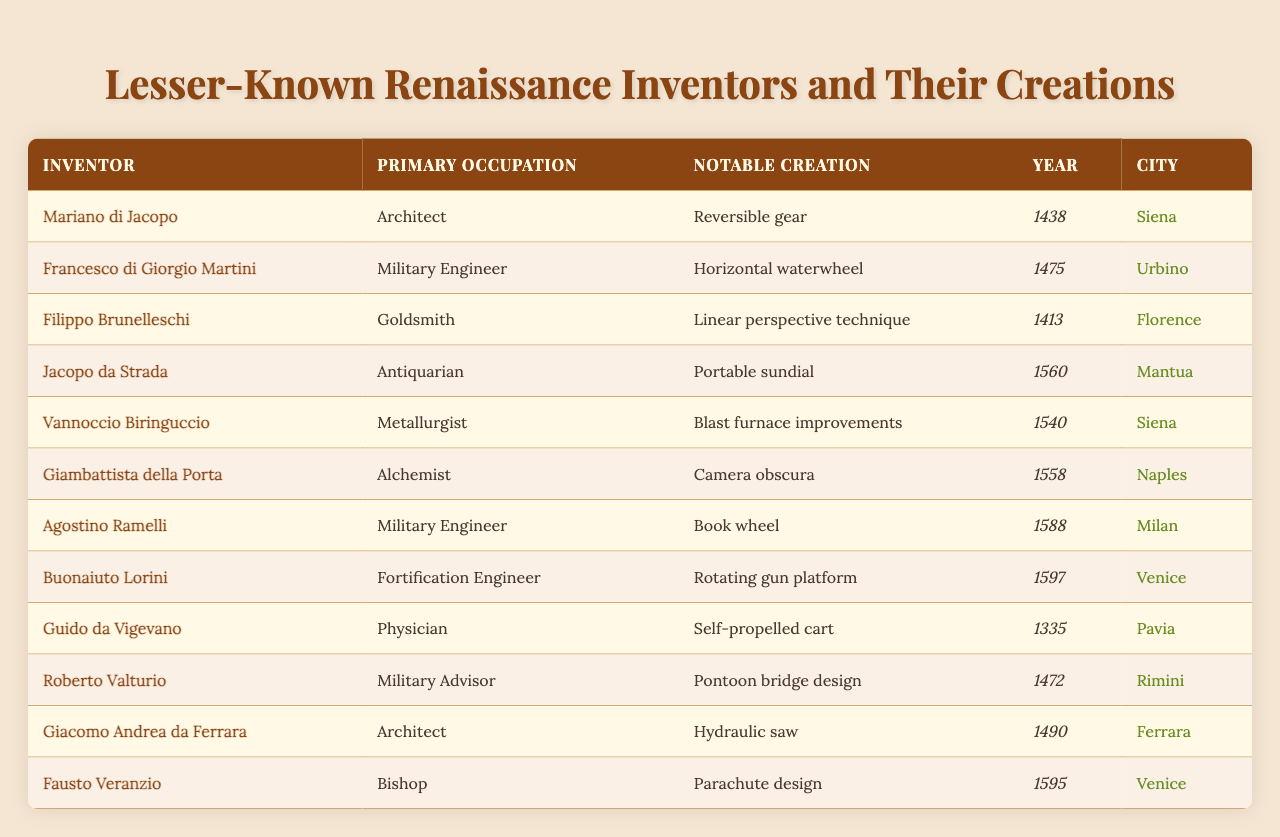What notable creation did Mariano di Jacopo invent? According to the table, Mariano di Jacopo's notable creation is the reversible gear.
Answer: Reversible gear In which city did Giambattista della Porta create the camera obscura? The table states that Giambattista della Porta created the camera obscura in Naples.
Answer: Naples Who was the military engineer responsible for the horizontal waterwheel? The table indicates that Francesco di Giorgio Martini was the military engineer who invented the horizontal waterwheel.
Answer: Francesco di Giorgio Martini What year was the parachute design proposed by Fausto Veranzio? The year listed for Fausto Veranzio's parachute design is 1595 according to the table.
Answer: 1595 How many inventors listed in the table were military engineers? The table shows that there are two military engineers: Francesco di Giorgio Martini and Agostino Ramelli.
Answer: 2 Which inventor from the table had a primary occupation as a physician? According to the table, Guido da Vigevano is identified as the only inventor whose primary occupation was a physician.
Answer: Guido da Vigevano Was the rotating gun platform invented before or after the self-propelled cart? The table shows that the self-propelled cart was created in 1335, while the rotating gun platform was invented in 1597, meaning the rotating gun platform was invented after the self-propelled cart.
Answer: After Which city had the most inventions listed in the table? By examining the table, we see that Siena has two inventions (the reversible gear and blast furnace improvements), while other cities have one, making Siena the city with the most inventions.
Answer: Siena What is the notable creation made by the architect Giacomo Andrea da Ferrara? The table reveals that Giacomo Andrea da Ferrara's notable creation is the hydraulic saw.
Answer: Hydraulic saw If we list the occupations of the inventors, how many different occupations are represented? The table lists the following distinct occupations: Architect, Military Engineer, Goldsmith, Antiquarian, Metallurgist, Alchemist, Fortification Engineer, Physician, and Military Advisor, totaling nine different occupations.
Answer: 9 